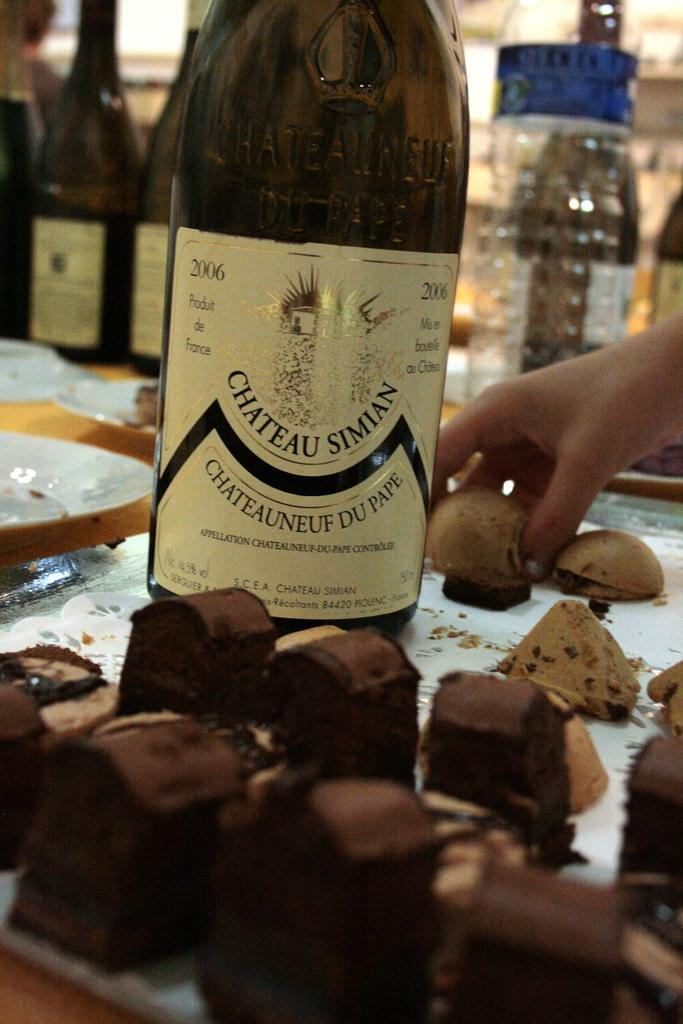What is on the tray in the image? There is a glass bottle on a tray in the image. What type of food can be seen in the image? There are cookies in the image. What is the person's hand doing in the image? A person's hand is holding a cookie in the image. What other objects can be seen in the background of the image? There are glass bottles and boxes in the background of the image. What type of wilderness can be seen in the image? There is no wilderness present in the image; it features a tray with a glass bottle and cookies, as well as a person's hand holding a cookie and objects in the background. 